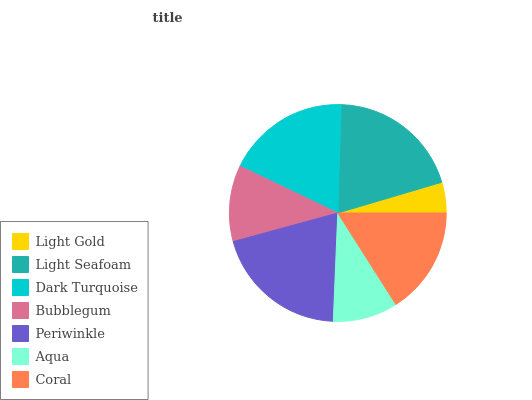Is Light Gold the minimum?
Answer yes or no. Yes. Is Periwinkle the maximum?
Answer yes or no. Yes. Is Light Seafoam the minimum?
Answer yes or no. No. Is Light Seafoam the maximum?
Answer yes or no. No. Is Light Seafoam greater than Light Gold?
Answer yes or no. Yes. Is Light Gold less than Light Seafoam?
Answer yes or no. Yes. Is Light Gold greater than Light Seafoam?
Answer yes or no. No. Is Light Seafoam less than Light Gold?
Answer yes or no. No. Is Coral the high median?
Answer yes or no. Yes. Is Coral the low median?
Answer yes or no. Yes. Is Dark Turquoise the high median?
Answer yes or no. No. Is Aqua the low median?
Answer yes or no. No. 